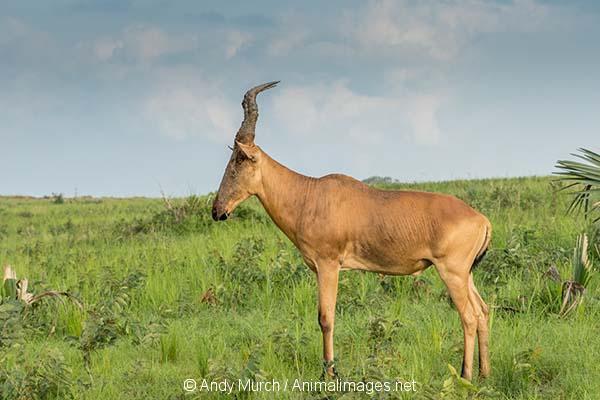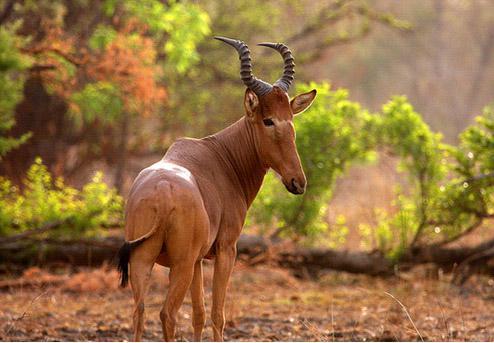The first image is the image on the left, the second image is the image on the right. For the images shown, is this caption "One of the animals is standing in left profile." true? Answer yes or no. Yes. The first image is the image on the left, the second image is the image on the right. For the images displayed, is the sentence "Each image contains just one horned animal, and the animals' faces and bodies are turned in different directions." factually correct? Answer yes or no. Yes. 